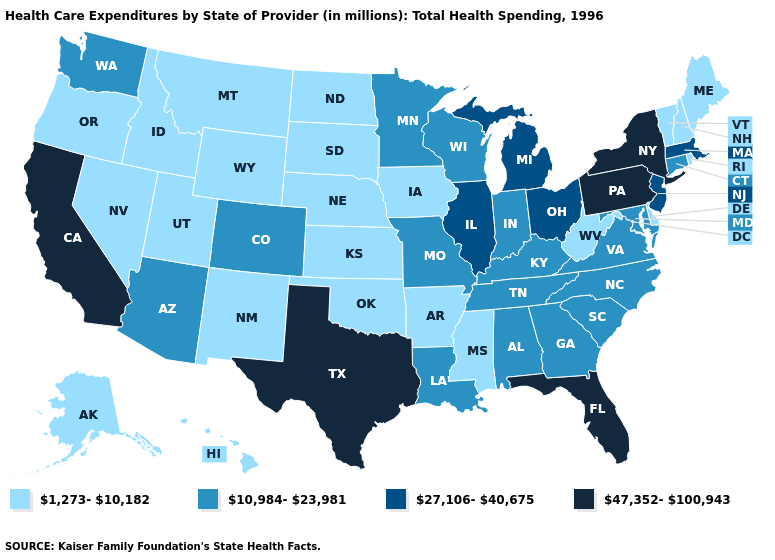Name the states that have a value in the range 27,106-40,675?
Quick response, please. Illinois, Massachusetts, Michigan, New Jersey, Ohio. Does the first symbol in the legend represent the smallest category?
Keep it brief. Yes. Does the map have missing data?
Be succinct. No. What is the value of California?
Write a very short answer. 47,352-100,943. Does Alaska have the lowest value in the USA?
Short answer required. Yes. What is the highest value in states that border Illinois?
Quick response, please. 10,984-23,981. Which states have the highest value in the USA?
Quick response, please. California, Florida, New York, Pennsylvania, Texas. What is the lowest value in the USA?
Be succinct. 1,273-10,182. Among the states that border New York , does Massachusetts have the lowest value?
Write a very short answer. No. What is the value of Utah?
Give a very brief answer. 1,273-10,182. What is the value of Michigan?
Quick response, please. 27,106-40,675. Among the states that border Massachusetts , does New York have the highest value?
Short answer required. Yes. Among the states that border Kentucky , which have the highest value?
Answer briefly. Illinois, Ohio. What is the highest value in states that border Kansas?
Be succinct. 10,984-23,981. 